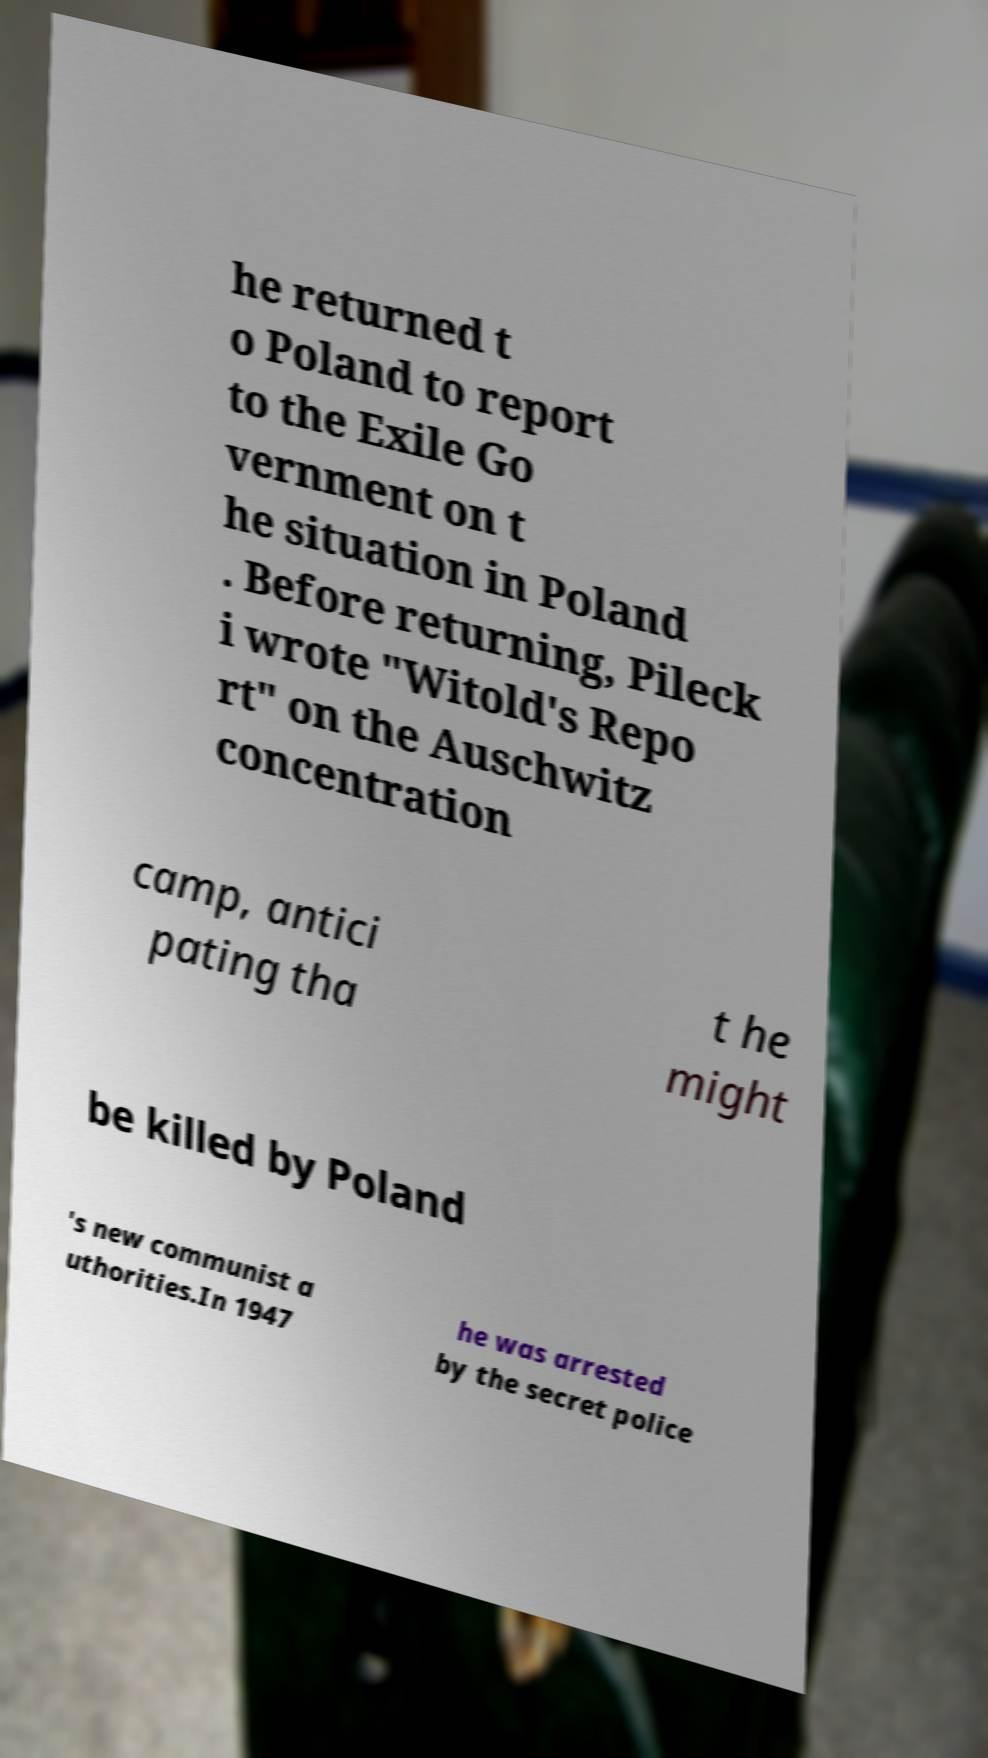For documentation purposes, I need the text within this image transcribed. Could you provide that? he returned t o Poland to report to the Exile Go vernment on t he situation in Poland . Before returning, Pileck i wrote "Witold's Repo rt" on the Auschwitz concentration camp, antici pating tha t he might be killed by Poland 's new communist a uthorities.In 1947 he was arrested by the secret police 